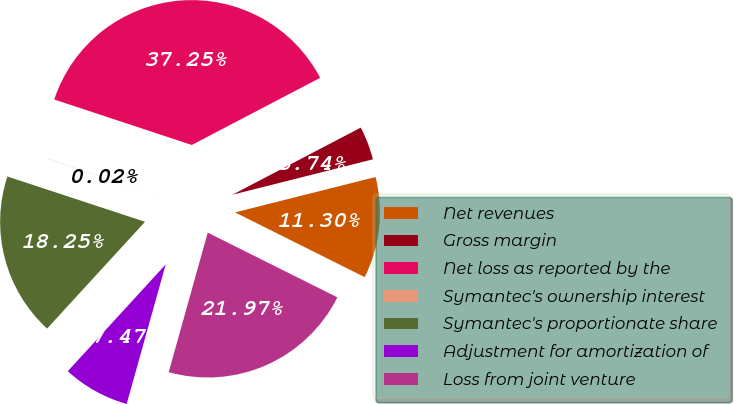Convert chart to OTSL. <chart><loc_0><loc_0><loc_500><loc_500><pie_chart><fcel>Net revenues<fcel>Gross margin<fcel>Net loss as reported by the<fcel>Symantec's ownership interest<fcel>Symantec's proportionate share<fcel>Adjustment for amortization of<fcel>Loss from joint venture<nl><fcel>11.3%<fcel>3.74%<fcel>37.25%<fcel>0.02%<fcel>18.25%<fcel>7.47%<fcel>21.97%<nl></chart> 